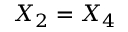Convert formula to latex. <formula><loc_0><loc_0><loc_500><loc_500>X _ { 2 } = X _ { 4 }</formula> 